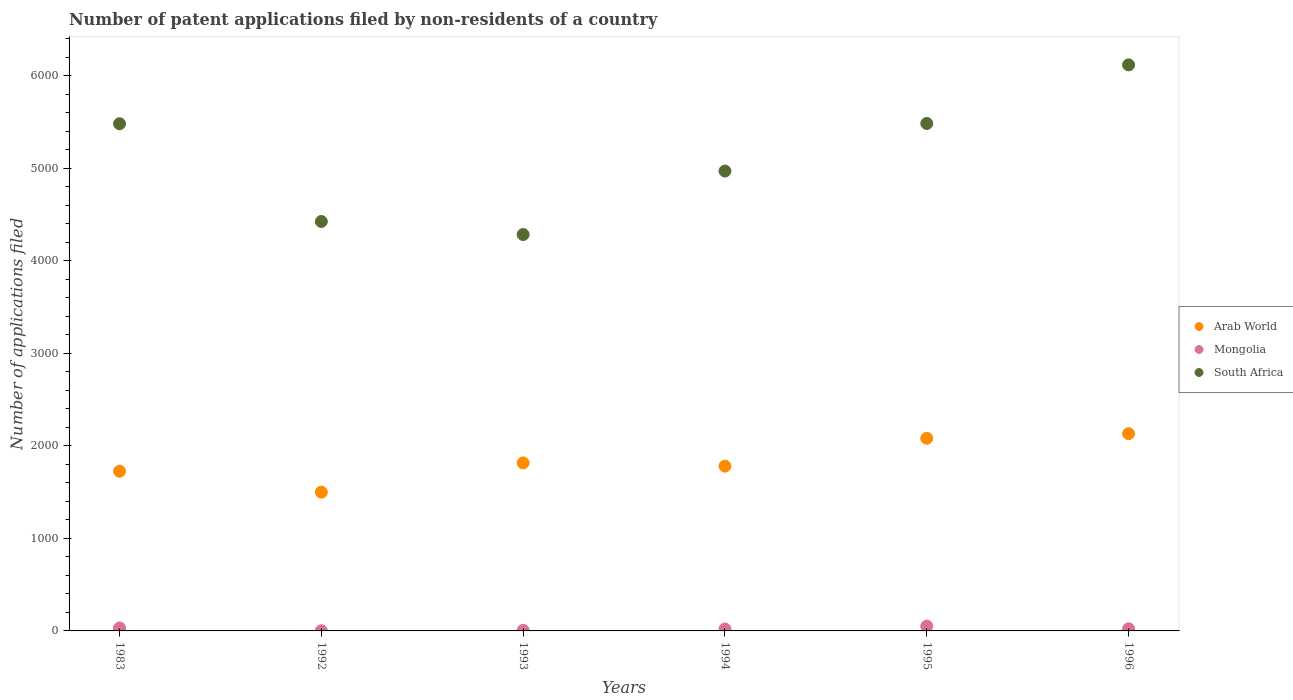How many different coloured dotlines are there?
Make the answer very short. 3. Is the number of dotlines equal to the number of legend labels?
Offer a terse response. Yes. What is the number of applications filed in South Africa in 1994?
Ensure brevity in your answer.  4968. Across all years, what is the maximum number of applications filed in Mongolia?
Offer a terse response. 52. Across all years, what is the minimum number of applications filed in Arab World?
Provide a succinct answer. 1499. In which year was the number of applications filed in Arab World maximum?
Keep it short and to the point. 1996. What is the total number of applications filed in Arab World in the graph?
Your answer should be compact. 1.10e+04. What is the difference between the number of applications filed in South Africa in 1994 and that in 1995?
Provide a succinct answer. -514. What is the difference between the number of applications filed in Arab World in 1993 and the number of applications filed in Mongolia in 1992?
Give a very brief answer. 1813. What is the average number of applications filed in Arab World per year?
Your answer should be very brief. 1838.5. In the year 1993, what is the difference between the number of applications filed in Arab World and number of applications filed in Mongolia?
Provide a short and direct response. 1809. What is the ratio of the number of applications filed in South Africa in 1992 to that in 1996?
Keep it short and to the point. 0.72. Is the difference between the number of applications filed in Arab World in 1992 and 1993 greater than the difference between the number of applications filed in Mongolia in 1992 and 1993?
Offer a terse response. No. What is the difference between the highest and the second highest number of applications filed in South Africa?
Your answer should be very brief. 633. What is the difference between the highest and the lowest number of applications filed in South Africa?
Your answer should be compact. 1833. In how many years, is the number of applications filed in Arab World greater than the average number of applications filed in Arab World taken over all years?
Provide a short and direct response. 2. Is the sum of the number of applications filed in Mongolia in 1983 and 1992 greater than the maximum number of applications filed in South Africa across all years?
Make the answer very short. No. Does the number of applications filed in South Africa monotonically increase over the years?
Your answer should be compact. No. Is the number of applications filed in South Africa strictly greater than the number of applications filed in Mongolia over the years?
Give a very brief answer. Yes. What is the difference between two consecutive major ticks on the Y-axis?
Your answer should be compact. 1000. Where does the legend appear in the graph?
Provide a short and direct response. Center right. What is the title of the graph?
Provide a succinct answer. Number of patent applications filed by non-residents of a country. Does "Guinea-Bissau" appear as one of the legend labels in the graph?
Give a very brief answer. No. What is the label or title of the X-axis?
Keep it short and to the point. Years. What is the label or title of the Y-axis?
Offer a very short reply. Number of applications filed. What is the Number of applications filed in Arab World in 1983?
Make the answer very short. 1725. What is the Number of applications filed in South Africa in 1983?
Your answer should be compact. 5479. What is the Number of applications filed of Arab World in 1992?
Your answer should be very brief. 1499. What is the Number of applications filed of Mongolia in 1992?
Keep it short and to the point. 2. What is the Number of applications filed of South Africa in 1992?
Offer a very short reply. 4423. What is the Number of applications filed of Arab World in 1993?
Your answer should be very brief. 1815. What is the Number of applications filed in South Africa in 1993?
Give a very brief answer. 4282. What is the Number of applications filed of Arab World in 1994?
Your answer should be compact. 1780. What is the Number of applications filed of South Africa in 1994?
Give a very brief answer. 4968. What is the Number of applications filed of Arab World in 1995?
Make the answer very short. 2081. What is the Number of applications filed in Mongolia in 1995?
Ensure brevity in your answer.  52. What is the Number of applications filed in South Africa in 1995?
Your answer should be very brief. 5482. What is the Number of applications filed in Arab World in 1996?
Your answer should be very brief. 2131. What is the Number of applications filed of South Africa in 1996?
Offer a terse response. 6115. Across all years, what is the maximum Number of applications filed of Arab World?
Your response must be concise. 2131. Across all years, what is the maximum Number of applications filed of Mongolia?
Your answer should be very brief. 52. Across all years, what is the maximum Number of applications filed of South Africa?
Your response must be concise. 6115. Across all years, what is the minimum Number of applications filed in Arab World?
Ensure brevity in your answer.  1499. Across all years, what is the minimum Number of applications filed of South Africa?
Your response must be concise. 4282. What is the total Number of applications filed of Arab World in the graph?
Your answer should be compact. 1.10e+04. What is the total Number of applications filed in Mongolia in the graph?
Your answer should be very brief. 136. What is the total Number of applications filed of South Africa in the graph?
Your response must be concise. 3.07e+04. What is the difference between the Number of applications filed of Arab World in 1983 and that in 1992?
Ensure brevity in your answer.  226. What is the difference between the Number of applications filed of Mongolia in 1983 and that in 1992?
Ensure brevity in your answer.  30. What is the difference between the Number of applications filed in South Africa in 1983 and that in 1992?
Make the answer very short. 1056. What is the difference between the Number of applications filed in Arab World in 1983 and that in 1993?
Provide a succinct answer. -90. What is the difference between the Number of applications filed of Mongolia in 1983 and that in 1993?
Make the answer very short. 26. What is the difference between the Number of applications filed in South Africa in 1983 and that in 1993?
Ensure brevity in your answer.  1197. What is the difference between the Number of applications filed of Arab World in 1983 and that in 1994?
Your answer should be compact. -55. What is the difference between the Number of applications filed of South Africa in 1983 and that in 1994?
Offer a terse response. 511. What is the difference between the Number of applications filed in Arab World in 1983 and that in 1995?
Your response must be concise. -356. What is the difference between the Number of applications filed in Mongolia in 1983 and that in 1995?
Ensure brevity in your answer.  -20. What is the difference between the Number of applications filed in South Africa in 1983 and that in 1995?
Keep it short and to the point. -3. What is the difference between the Number of applications filed of Arab World in 1983 and that in 1996?
Provide a succinct answer. -406. What is the difference between the Number of applications filed in Mongolia in 1983 and that in 1996?
Offer a very short reply. 9. What is the difference between the Number of applications filed of South Africa in 1983 and that in 1996?
Offer a terse response. -636. What is the difference between the Number of applications filed of Arab World in 1992 and that in 1993?
Give a very brief answer. -316. What is the difference between the Number of applications filed of South Africa in 1992 and that in 1993?
Provide a short and direct response. 141. What is the difference between the Number of applications filed of Arab World in 1992 and that in 1994?
Give a very brief answer. -281. What is the difference between the Number of applications filed of South Africa in 1992 and that in 1994?
Ensure brevity in your answer.  -545. What is the difference between the Number of applications filed of Arab World in 1992 and that in 1995?
Make the answer very short. -582. What is the difference between the Number of applications filed of South Africa in 1992 and that in 1995?
Give a very brief answer. -1059. What is the difference between the Number of applications filed of Arab World in 1992 and that in 1996?
Give a very brief answer. -632. What is the difference between the Number of applications filed in South Africa in 1992 and that in 1996?
Make the answer very short. -1692. What is the difference between the Number of applications filed in Arab World in 1993 and that in 1994?
Provide a succinct answer. 35. What is the difference between the Number of applications filed in Mongolia in 1993 and that in 1994?
Ensure brevity in your answer.  -15. What is the difference between the Number of applications filed of South Africa in 1993 and that in 1994?
Provide a succinct answer. -686. What is the difference between the Number of applications filed in Arab World in 1993 and that in 1995?
Your answer should be compact. -266. What is the difference between the Number of applications filed in Mongolia in 1993 and that in 1995?
Your answer should be very brief. -46. What is the difference between the Number of applications filed of South Africa in 1993 and that in 1995?
Ensure brevity in your answer.  -1200. What is the difference between the Number of applications filed of Arab World in 1993 and that in 1996?
Your answer should be very brief. -316. What is the difference between the Number of applications filed of South Africa in 1993 and that in 1996?
Give a very brief answer. -1833. What is the difference between the Number of applications filed of Arab World in 1994 and that in 1995?
Your response must be concise. -301. What is the difference between the Number of applications filed of Mongolia in 1994 and that in 1995?
Provide a short and direct response. -31. What is the difference between the Number of applications filed of South Africa in 1994 and that in 1995?
Your answer should be very brief. -514. What is the difference between the Number of applications filed in Arab World in 1994 and that in 1996?
Your answer should be compact. -351. What is the difference between the Number of applications filed in South Africa in 1994 and that in 1996?
Your response must be concise. -1147. What is the difference between the Number of applications filed of South Africa in 1995 and that in 1996?
Provide a short and direct response. -633. What is the difference between the Number of applications filed of Arab World in 1983 and the Number of applications filed of Mongolia in 1992?
Provide a short and direct response. 1723. What is the difference between the Number of applications filed of Arab World in 1983 and the Number of applications filed of South Africa in 1992?
Your answer should be very brief. -2698. What is the difference between the Number of applications filed in Mongolia in 1983 and the Number of applications filed in South Africa in 1992?
Your response must be concise. -4391. What is the difference between the Number of applications filed of Arab World in 1983 and the Number of applications filed of Mongolia in 1993?
Keep it short and to the point. 1719. What is the difference between the Number of applications filed in Arab World in 1983 and the Number of applications filed in South Africa in 1993?
Provide a short and direct response. -2557. What is the difference between the Number of applications filed in Mongolia in 1983 and the Number of applications filed in South Africa in 1993?
Ensure brevity in your answer.  -4250. What is the difference between the Number of applications filed in Arab World in 1983 and the Number of applications filed in Mongolia in 1994?
Make the answer very short. 1704. What is the difference between the Number of applications filed of Arab World in 1983 and the Number of applications filed of South Africa in 1994?
Your response must be concise. -3243. What is the difference between the Number of applications filed in Mongolia in 1983 and the Number of applications filed in South Africa in 1994?
Your answer should be compact. -4936. What is the difference between the Number of applications filed of Arab World in 1983 and the Number of applications filed of Mongolia in 1995?
Your answer should be compact. 1673. What is the difference between the Number of applications filed in Arab World in 1983 and the Number of applications filed in South Africa in 1995?
Your response must be concise. -3757. What is the difference between the Number of applications filed of Mongolia in 1983 and the Number of applications filed of South Africa in 1995?
Make the answer very short. -5450. What is the difference between the Number of applications filed of Arab World in 1983 and the Number of applications filed of Mongolia in 1996?
Your answer should be compact. 1702. What is the difference between the Number of applications filed in Arab World in 1983 and the Number of applications filed in South Africa in 1996?
Ensure brevity in your answer.  -4390. What is the difference between the Number of applications filed of Mongolia in 1983 and the Number of applications filed of South Africa in 1996?
Provide a short and direct response. -6083. What is the difference between the Number of applications filed of Arab World in 1992 and the Number of applications filed of Mongolia in 1993?
Ensure brevity in your answer.  1493. What is the difference between the Number of applications filed in Arab World in 1992 and the Number of applications filed in South Africa in 1993?
Provide a succinct answer. -2783. What is the difference between the Number of applications filed in Mongolia in 1992 and the Number of applications filed in South Africa in 1993?
Ensure brevity in your answer.  -4280. What is the difference between the Number of applications filed of Arab World in 1992 and the Number of applications filed of Mongolia in 1994?
Your answer should be very brief. 1478. What is the difference between the Number of applications filed of Arab World in 1992 and the Number of applications filed of South Africa in 1994?
Your response must be concise. -3469. What is the difference between the Number of applications filed of Mongolia in 1992 and the Number of applications filed of South Africa in 1994?
Provide a succinct answer. -4966. What is the difference between the Number of applications filed of Arab World in 1992 and the Number of applications filed of Mongolia in 1995?
Offer a very short reply. 1447. What is the difference between the Number of applications filed of Arab World in 1992 and the Number of applications filed of South Africa in 1995?
Make the answer very short. -3983. What is the difference between the Number of applications filed in Mongolia in 1992 and the Number of applications filed in South Africa in 1995?
Keep it short and to the point. -5480. What is the difference between the Number of applications filed in Arab World in 1992 and the Number of applications filed in Mongolia in 1996?
Keep it short and to the point. 1476. What is the difference between the Number of applications filed of Arab World in 1992 and the Number of applications filed of South Africa in 1996?
Your answer should be compact. -4616. What is the difference between the Number of applications filed of Mongolia in 1992 and the Number of applications filed of South Africa in 1996?
Provide a short and direct response. -6113. What is the difference between the Number of applications filed in Arab World in 1993 and the Number of applications filed in Mongolia in 1994?
Your response must be concise. 1794. What is the difference between the Number of applications filed in Arab World in 1993 and the Number of applications filed in South Africa in 1994?
Ensure brevity in your answer.  -3153. What is the difference between the Number of applications filed of Mongolia in 1993 and the Number of applications filed of South Africa in 1994?
Your answer should be very brief. -4962. What is the difference between the Number of applications filed in Arab World in 1993 and the Number of applications filed in Mongolia in 1995?
Ensure brevity in your answer.  1763. What is the difference between the Number of applications filed in Arab World in 1993 and the Number of applications filed in South Africa in 1995?
Provide a short and direct response. -3667. What is the difference between the Number of applications filed of Mongolia in 1993 and the Number of applications filed of South Africa in 1995?
Provide a succinct answer. -5476. What is the difference between the Number of applications filed in Arab World in 1993 and the Number of applications filed in Mongolia in 1996?
Ensure brevity in your answer.  1792. What is the difference between the Number of applications filed in Arab World in 1993 and the Number of applications filed in South Africa in 1996?
Ensure brevity in your answer.  -4300. What is the difference between the Number of applications filed in Mongolia in 1993 and the Number of applications filed in South Africa in 1996?
Offer a terse response. -6109. What is the difference between the Number of applications filed in Arab World in 1994 and the Number of applications filed in Mongolia in 1995?
Offer a terse response. 1728. What is the difference between the Number of applications filed in Arab World in 1994 and the Number of applications filed in South Africa in 1995?
Your response must be concise. -3702. What is the difference between the Number of applications filed of Mongolia in 1994 and the Number of applications filed of South Africa in 1995?
Offer a terse response. -5461. What is the difference between the Number of applications filed in Arab World in 1994 and the Number of applications filed in Mongolia in 1996?
Provide a succinct answer. 1757. What is the difference between the Number of applications filed of Arab World in 1994 and the Number of applications filed of South Africa in 1996?
Make the answer very short. -4335. What is the difference between the Number of applications filed of Mongolia in 1994 and the Number of applications filed of South Africa in 1996?
Provide a succinct answer. -6094. What is the difference between the Number of applications filed of Arab World in 1995 and the Number of applications filed of Mongolia in 1996?
Your answer should be very brief. 2058. What is the difference between the Number of applications filed of Arab World in 1995 and the Number of applications filed of South Africa in 1996?
Provide a succinct answer. -4034. What is the difference between the Number of applications filed of Mongolia in 1995 and the Number of applications filed of South Africa in 1996?
Keep it short and to the point. -6063. What is the average Number of applications filed in Arab World per year?
Provide a succinct answer. 1838.5. What is the average Number of applications filed of Mongolia per year?
Make the answer very short. 22.67. What is the average Number of applications filed in South Africa per year?
Your response must be concise. 5124.83. In the year 1983, what is the difference between the Number of applications filed in Arab World and Number of applications filed in Mongolia?
Provide a short and direct response. 1693. In the year 1983, what is the difference between the Number of applications filed in Arab World and Number of applications filed in South Africa?
Keep it short and to the point. -3754. In the year 1983, what is the difference between the Number of applications filed of Mongolia and Number of applications filed of South Africa?
Your answer should be compact. -5447. In the year 1992, what is the difference between the Number of applications filed of Arab World and Number of applications filed of Mongolia?
Ensure brevity in your answer.  1497. In the year 1992, what is the difference between the Number of applications filed of Arab World and Number of applications filed of South Africa?
Offer a terse response. -2924. In the year 1992, what is the difference between the Number of applications filed of Mongolia and Number of applications filed of South Africa?
Your answer should be very brief. -4421. In the year 1993, what is the difference between the Number of applications filed of Arab World and Number of applications filed of Mongolia?
Offer a very short reply. 1809. In the year 1993, what is the difference between the Number of applications filed of Arab World and Number of applications filed of South Africa?
Make the answer very short. -2467. In the year 1993, what is the difference between the Number of applications filed of Mongolia and Number of applications filed of South Africa?
Keep it short and to the point. -4276. In the year 1994, what is the difference between the Number of applications filed in Arab World and Number of applications filed in Mongolia?
Provide a succinct answer. 1759. In the year 1994, what is the difference between the Number of applications filed in Arab World and Number of applications filed in South Africa?
Provide a succinct answer. -3188. In the year 1994, what is the difference between the Number of applications filed of Mongolia and Number of applications filed of South Africa?
Give a very brief answer. -4947. In the year 1995, what is the difference between the Number of applications filed of Arab World and Number of applications filed of Mongolia?
Your answer should be very brief. 2029. In the year 1995, what is the difference between the Number of applications filed of Arab World and Number of applications filed of South Africa?
Provide a short and direct response. -3401. In the year 1995, what is the difference between the Number of applications filed of Mongolia and Number of applications filed of South Africa?
Offer a very short reply. -5430. In the year 1996, what is the difference between the Number of applications filed in Arab World and Number of applications filed in Mongolia?
Give a very brief answer. 2108. In the year 1996, what is the difference between the Number of applications filed in Arab World and Number of applications filed in South Africa?
Your answer should be compact. -3984. In the year 1996, what is the difference between the Number of applications filed of Mongolia and Number of applications filed of South Africa?
Keep it short and to the point. -6092. What is the ratio of the Number of applications filed of Arab World in 1983 to that in 1992?
Your answer should be very brief. 1.15. What is the ratio of the Number of applications filed of Mongolia in 1983 to that in 1992?
Your response must be concise. 16. What is the ratio of the Number of applications filed of South Africa in 1983 to that in 1992?
Offer a very short reply. 1.24. What is the ratio of the Number of applications filed in Arab World in 1983 to that in 1993?
Give a very brief answer. 0.95. What is the ratio of the Number of applications filed in Mongolia in 1983 to that in 1993?
Offer a very short reply. 5.33. What is the ratio of the Number of applications filed in South Africa in 1983 to that in 1993?
Give a very brief answer. 1.28. What is the ratio of the Number of applications filed of Arab World in 1983 to that in 1994?
Ensure brevity in your answer.  0.97. What is the ratio of the Number of applications filed in Mongolia in 1983 to that in 1994?
Ensure brevity in your answer.  1.52. What is the ratio of the Number of applications filed in South Africa in 1983 to that in 1994?
Offer a terse response. 1.1. What is the ratio of the Number of applications filed of Arab World in 1983 to that in 1995?
Ensure brevity in your answer.  0.83. What is the ratio of the Number of applications filed in Mongolia in 1983 to that in 1995?
Make the answer very short. 0.62. What is the ratio of the Number of applications filed of South Africa in 1983 to that in 1995?
Offer a very short reply. 1. What is the ratio of the Number of applications filed of Arab World in 1983 to that in 1996?
Your answer should be compact. 0.81. What is the ratio of the Number of applications filed of Mongolia in 1983 to that in 1996?
Offer a very short reply. 1.39. What is the ratio of the Number of applications filed of South Africa in 1983 to that in 1996?
Provide a succinct answer. 0.9. What is the ratio of the Number of applications filed in Arab World in 1992 to that in 1993?
Make the answer very short. 0.83. What is the ratio of the Number of applications filed of South Africa in 1992 to that in 1993?
Provide a succinct answer. 1.03. What is the ratio of the Number of applications filed in Arab World in 1992 to that in 1994?
Make the answer very short. 0.84. What is the ratio of the Number of applications filed in Mongolia in 1992 to that in 1994?
Offer a terse response. 0.1. What is the ratio of the Number of applications filed in South Africa in 1992 to that in 1994?
Your answer should be very brief. 0.89. What is the ratio of the Number of applications filed of Arab World in 1992 to that in 1995?
Provide a short and direct response. 0.72. What is the ratio of the Number of applications filed in Mongolia in 1992 to that in 1995?
Give a very brief answer. 0.04. What is the ratio of the Number of applications filed of South Africa in 1992 to that in 1995?
Your answer should be very brief. 0.81. What is the ratio of the Number of applications filed in Arab World in 1992 to that in 1996?
Ensure brevity in your answer.  0.7. What is the ratio of the Number of applications filed of Mongolia in 1992 to that in 1996?
Offer a very short reply. 0.09. What is the ratio of the Number of applications filed in South Africa in 1992 to that in 1996?
Make the answer very short. 0.72. What is the ratio of the Number of applications filed in Arab World in 1993 to that in 1994?
Offer a terse response. 1.02. What is the ratio of the Number of applications filed in Mongolia in 1993 to that in 1994?
Your answer should be compact. 0.29. What is the ratio of the Number of applications filed of South Africa in 1993 to that in 1994?
Keep it short and to the point. 0.86. What is the ratio of the Number of applications filed of Arab World in 1993 to that in 1995?
Ensure brevity in your answer.  0.87. What is the ratio of the Number of applications filed in Mongolia in 1993 to that in 1995?
Make the answer very short. 0.12. What is the ratio of the Number of applications filed in South Africa in 1993 to that in 1995?
Keep it short and to the point. 0.78. What is the ratio of the Number of applications filed of Arab World in 1993 to that in 1996?
Offer a very short reply. 0.85. What is the ratio of the Number of applications filed in Mongolia in 1993 to that in 1996?
Make the answer very short. 0.26. What is the ratio of the Number of applications filed of South Africa in 1993 to that in 1996?
Your answer should be very brief. 0.7. What is the ratio of the Number of applications filed of Arab World in 1994 to that in 1995?
Your response must be concise. 0.86. What is the ratio of the Number of applications filed in Mongolia in 1994 to that in 1995?
Give a very brief answer. 0.4. What is the ratio of the Number of applications filed in South Africa in 1994 to that in 1995?
Provide a short and direct response. 0.91. What is the ratio of the Number of applications filed of Arab World in 1994 to that in 1996?
Provide a succinct answer. 0.84. What is the ratio of the Number of applications filed in Mongolia in 1994 to that in 1996?
Provide a short and direct response. 0.91. What is the ratio of the Number of applications filed in South Africa in 1994 to that in 1996?
Your response must be concise. 0.81. What is the ratio of the Number of applications filed of Arab World in 1995 to that in 1996?
Provide a succinct answer. 0.98. What is the ratio of the Number of applications filed of Mongolia in 1995 to that in 1996?
Offer a terse response. 2.26. What is the ratio of the Number of applications filed of South Africa in 1995 to that in 1996?
Your answer should be compact. 0.9. What is the difference between the highest and the second highest Number of applications filed in Arab World?
Ensure brevity in your answer.  50. What is the difference between the highest and the second highest Number of applications filed of South Africa?
Offer a very short reply. 633. What is the difference between the highest and the lowest Number of applications filed of Arab World?
Offer a very short reply. 632. What is the difference between the highest and the lowest Number of applications filed in South Africa?
Offer a very short reply. 1833. 